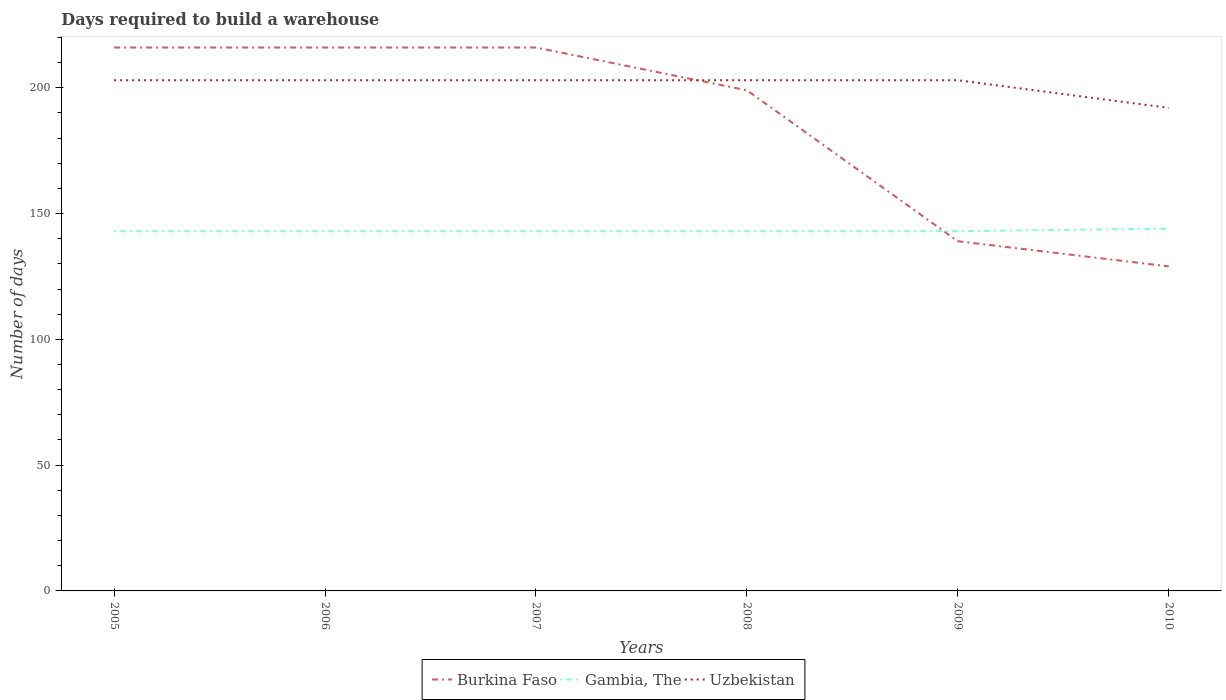Does the line corresponding to Uzbekistan intersect with the line corresponding to Burkina Faso?
Provide a short and direct response. Yes. Across all years, what is the maximum days required to build a warehouse in in Uzbekistan?
Your answer should be very brief. 192. In which year was the days required to build a warehouse in in Uzbekistan maximum?
Offer a very short reply. 2010. What is the total days required to build a warehouse in in Burkina Faso in the graph?
Offer a very short reply. 87. What is the difference between the highest and the second highest days required to build a warehouse in in Gambia, The?
Your response must be concise. 1. Is the days required to build a warehouse in in Uzbekistan strictly greater than the days required to build a warehouse in in Gambia, The over the years?
Keep it short and to the point. No. How many years are there in the graph?
Your answer should be compact. 6. Does the graph contain any zero values?
Provide a short and direct response. No. Does the graph contain grids?
Your answer should be compact. No. What is the title of the graph?
Ensure brevity in your answer.  Days required to build a warehouse. What is the label or title of the X-axis?
Provide a short and direct response. Years. What is the label or title of the Y-axis?
Keep it short and to the point. Number of days. What is the Number of days in Burkina Faso in 2005?
Your answer should be compact. 216. What is the Number of days of Gambia, The in 2005?
Give a very brief answer. 143. What is the Number of days in Uzbekistan in 2005?
Your answer should be compact. 203. What is the Number of days of Burkina Faso in 2006?
Give a very brief answer. 216. What is the Number of days of Gambia, The in 2006?
Offer a very short reply. 143. What is the Number of days in Uzbekistan in 2006?
Keep it short and to the point. 203. What is the Number of days in Burkina Faso in 2007?
Offer a terse response. 216. What is the Number of days of Gambia, The in 2007?
Give a very brief answer. 143. What is the Number of days in Uzbekistan in 2007?
Offer a very short reply. 203. What is the Number of days in Burkina Faso in 2008?
Give a very brief answer. 199. What is the Number of days in Gambia, The in 2008?
Give a very brief answer. 143. What is the Number of days in Uzbekistan in 2008?
Keep it short and to the point. 203. What is the Number of days in Burkina Faso in 2009?
Your answer should be compact. 139. What is the Number of days in Gambia, The in 2009?
Make the answer very short. 143. What is the Number of days of Uzbekistan in 2009?
Offer a terse response. 203. What is the Number of days of Burkina Faso in 2010?
Give a very brief answer. 129. What is the Number of days in Gambia, The in 2010?
Keep it short and to the point. 144. What is the Number of days in Uzbekistan in 2010?
Offer a terse response. 192. Across all years, what is the maximum Number of days in Burkina Faso?
Keep it short and to the point. 216. Across all years, what is the maximum Number of days of Gambia, The?
Ensure brevity in your answer.  144. Across all years, what is the maximum Number of days in Uzbekistan?
Ensure brevity in your answer.  203. Across all years, what is the minimum Number of days of Burkina Faso?
Provide a succinct answer. 129. Across all years, what is the minimum Number of days in Gambia, The?
Your answer should be compact. 143. Across all years, what is the minimum Number of days in Uzbekistan?
Give a very brief answer. 192. What is the total Number of days of Burkina Faso in the graph?
Ensure brevity in your answer.  1115. What is the total Number of days in Gambia, The in the graph?
Offer a very short reply. 859. What is the total Number of days of Uzbekistan in the graph?
Provide a succinct answer. 1207. What is the difference between the Number of days in Uzbekistan in 2005 and that in 2006?
Keep it short and to the point. 0. What is the difference between the Number of days of Burkina Faso in 2005 and that in 2007?
Your response must be concise. 0. What is the difference between the Number of days of Gambia, The in 2005 and that in 2007?
Your response must be concise. 0. What is the difference between the Number of days in Uzbekistan in 2005 and that in 2007?
Make the answer very short. 0. What is the difference between the Number of days of Burkina Faso in 2005 and that in 2008?
Ensure brevity in your answer.  17. What is the difference between the Number of days in Gambia, The in 2005 and that in 2008?
Ensure brevity in your answer.  0. What is the difference between the Number of days of Uzbekistan in 2005 and that in 2008?
Your answer should be compact. 0. What is the difference between the Number of days in Gambia, The in 2005 and that in 2009?
Offer a terse response. 0. What is the difference between the Number of days in Uzbekistan in 2005 and that in 2010?
Offer a terse response. 11. What is the difference between the Number of days of Burkina Faso in 2006 and that in 2007?
Provide a succinct answer. 0. What is the difference between the Number of days of Uzbekistan in 2006 and that in 2007?
Provide a short and direct response. 0. What is the difference between the Number of days of Uzbekistan in 2006 and that in 2008?
Your response must be concise. 0. What is the difference between the Number of days in Burkina Faso in 2006 and that in 2010?
Your answer should be compact. 87. What is the difference between the Number of days of Uzbekistan in 2006 and that in 2010?
Your response must be concise. 11. What is the difference between the Number of days of Burkina Faso in 2007 and that in 2008?
Provide a short and direct response. 17. What is the difference between the Number of days of Uzbekistan in 2007 and that in 2008?
Make the answer very short. 0. What is the difference between the Number of days in Burkina Faso in 2007 and that in 2009?
Your response must be concise. 77. What is the difference between the Number of days in Gambia, The in 2007 and that in 2009?
Your answer should be compact. 0. What is the difference between the Number of days in Gambia, The in 2007 and that in 2010?
Your answer should be compact. -1. What is the difference between the Number of days in Uzbekistan in 2007 and that in 2010?
Your answer should be very brief. 11. What is the difference between the Number of days in Uzbekistan in 2008 and that in 2009?
Make the answer very short. 0. What is the difference between the Number of days of Gambia, The in 2008 and that in 2010?
Give a very brief answer. -1. What is the difference between the Number of days of Uzbekistan in 2008 and that in 2010?
Make the answer very short. 11. What is the difference between the Number of days of Gambia, The in 2005 and the Number of days of Uzbekistan in 2006?
Offer a very short reply. -60. What is the difference between the Number of days in Burkina Faso in 2005 and the Number of days in Uzbekistan in 2007?
Make the answer very short. 13. What is the difference between the Number of days in Gambia, The in 2005 and the Number of days in Uzbekistan in 2007?
Offer a very short reply. -60. What is the difference between the Number of days of Burkina Faso in 2005 and the Number of days of Gambia, The in 2008?
Offer a very short reply. 73. What is the difference between the Number of days of Burkina Faso in 2005 and the Number of days of Uzbekistan in 2008?
Make the answer very short. 13. What is the difference between the Number of days of Gambia, The in 2005 and the Number of days of Uzbekistan in 2008?
Make the answer very short. -60. What is the difference between the Number of days of Gambia, The in 2005 and the Number of days of Uzbekistan in 2009?
Your response must be concise. -60. What is the difference between the Number of days of Burkina Faso in 2005 and the Number of days of Gambia, The in 2010?
Give a very brief answer. 72. What is the difference between the Number of days in Burkina Faso in 2005 and the Number of days in Uzbekistan in 2010?
Give a very brief answer. 24. What is the difference between the Number of days in Gambia, The in 2005 and the Number of days in Uzbekistan in 2010?
Provide a succinct answer. -49. What is the difference between the Number of days in Burkina Faso in 2006 and the Number of days in Gambia, The in 2007?
Keep it short and to the point. 73. What is the difference between the Number of days in Gambia, The in 2006 and the Number of days in Uzbekistan in 2007?
Your answer should be compact. -60. What is the difference between the Number of days of Burkina Faso in 2006 and the Number of days of Gambia, The in 2008?
Provide a short and direct response. 73. What is the difference between the Number of days of Gambia, The in 2006 and the Number of days of Uzbekistan in 2008?
Give a very brief answer. -60. What is the difference between the Number of days of Burkina Faso in 2006 and the Number of days of Uzbekistan in 2009?
Offer a very short reply. 13. What is the difference between the Number of days in Gambia, The in 2006 and the Number of days in Uzbekistan in 2009?
Ensure brevity in your answer.  -60. What is the difference between the Number of days of Burkina Faso in 2006 and the Number of days of Gambia, The in 2010?
Keep it short and to the point. 72. What is the difference between the Number of days in Burkina Faso in 2006 and the Number of days in Uzbekistan in 2010?
Offer a terse response. 24. What is the difference between the Number of days of Gambia, The in 2006 and the Number of days of Uzbekistan in 2010?
Keep it short and to the point. -49. What is the difference between the Number of days in Burkina Faso in 2007 and the Number of days in Gambia, The in 2008?
Ensure brevity in your answer.  73. What is the difference between the Number of days of Burkina Faso in 2007 and the Number of days of Uzbekistan in 2008?
Keep it short and to the point. 13. What is the difference between the Number of days in Gambia, The in 2007 and the Number of days in Uzbekistan in 2008?
Keep it short and to the point. -60. What is the difference between the Number of days in Burkina Faso in 2007 and the Number of days in Gambia, The in 2009?
Make the answer very short. 73. What is the difference between the Number of days of Gambia, The in 2007 and the Number of days of Uzbekistan in 2009?
Your answer should be compact. -60. What is the difference between the Number of days in Burkina Faso in 2007 and the Number of days in Uzbekistan in 2010?
Offer a terse response. 24. What is the difference between the Number of days in Gambia, The in 2007 and the Number of days in Uzbekistan in 2010?
Your answer should be compact. -49. What is the difference between the Number of days of Burkina Faso in 2008 and the Number of days of Gambia, The in 2009?
Give a very brief answer. 56. What is the difference between the Number of days of Gambia, The in 2008 and the Number of days of Uzbekistan in 2009?
Provide a succinct answer. -60. What is the difference between the Number of days in Burkina Faso in 2008 and the Number of days in Gambia, The in 2010?
Give a very brief answer. 55. What is the difference between the Number of days of Burkina Faso in 2008 and the Number of days of Uzbekistan in 2010?
Offer a terse response. 7. What is the difference between the Number of days in Gambia, The in 2008 and the Number of days in Uzbekistan in 2010?
Your response must be concise. -49. What is the difference between the Number of days in Burkina Faso in 2009 and the Number of days in Gambia, The in 2010?
Ensure brevity in your answer.  -5. What is the difference between the Number of days in Burkina Faso in 2009 and the Number of days in Uzbekistan in 2010?
Provide a succinct answer. -53. What is the difference between the Number of days in Gambia, The in 2009 and the Number of days in Uzbekistan in 2010?
Offer a very short reply. -49. What is the average Number of days of Burkina Faso per year?
Offer a very short reply. 185.83. What is the average Number of days in Gambia, The per year?
Give a very brief answer. 143.17. What is the average Number of days of Uzbekistan per year?
Make the answer very short. 201.17. In the year 2005, what is the difference between the Number of days in Gambia, The and Number of days in Uzbekistan?
Provide a succinct answer. -60. In the year 2006, what is the difference between the Number of days of Burkina Faso and Number of days of Gambia, The?
Make the answer very short. 73. In the year 2006, what is the difference between the Number of days in Burkina Faso and Number of days in Uzbekistan?
Offer a very short reply. 13. In the year 2006, what is the difference between the Number of days of Gambia, The and Number of days of Uzbekistan?
Keep it short and to the point. -60. In the year 2007, what is the difference between the Number of days of Burkina Faso and Number of days of Gambia, The?
Ensure brevity in your answer.  73. In the year 2007, what is the difference between the Number of days of Burkina Faso and Number of days of Uzbekistan?
Keep it short and to the point. 13. In the year 2007, what is the difference between the Number of days in Gambia, The and Number of days in Uzbekistan?
Give a very brief answer. -60. In the year 2008, what is the difference between the Number of days of Burkina Faso and Number of days of Gambia, The?
Provide a short and direct response. 56. In the year 2008, what is the difference between the Number of days of Gambia, The and Number of days of Uzbekistan?
Provide a short and direct response. -60. In the year 2009, what is the difference between the Number of days of Burkina Faso and Number of days of Gambia, The?
Your answer should be very brief. -4. In the year 2009, what is the difference between the Number of days in Burkina Faso and Number of days in Uzbekistan?
Your answer should be compact. -64. In the year 2009, what is the difference between the Number of days in Gambia, The and Number of days in Uzbekistan?
Offer a terse response. -60. In the year 2010, what is the difference between the Number of days of Burkina Faso and Number of days of Gambia, The?
Your answer should be very brief. -15. In the year 2010, what is the difference between the Number of days in Burkina Faso and Number of days in Uzbekistan?
Keep it short and to the point. -63. In the year 2010, what is the difference between the Number of days of Gambia, The and Number of days of Uzbekistan?
Offer a terse response. -48. What is the ratio of the Number of days of Burkina Faso in 2005 to that in 2006?
Ensure brevity in your answer.  1. What is the ratio of the Number of days of Gambia, The in 2005 to that in 2006?
Offer a terse response. 1. What is the ratio of the Number of days of Gambia, The in 2005 to that in 2007?
Offer a terse response. 1. What is the ratio of the Number of days of Uzbekistan in 2005 to that in 2007?
Keep it short and to the point. 1. What is the ratio of the Number of days of Burkina Faso in 2005 to that in 2008?
Provide a succinct answer. 1.09. What is the ratio of the Number of days of Uzbekistan in 2005 to that in 2008?
Your answer should be compact. 1. What is the ratio of the Number of days of Burkina Faso in 2005 to that in 2009?
Your answer should be compact. 1.55. What is the ratio of the Number of days of Gambia, The in 2005 to that in 2009?
Give a very brief answer. 1. What is the ratio of the Number of days in Uzbekistan in 2005 to that in 2009?
Give a very brief answer. 1. What is the ratio of the Number of days in Burkina Faso in 2005 to that in 2010?
Provide a succinct answer. 1.67. What is the ratio of the Number of days in Uzbekistan in 2005 to that in 2010?
Make the answer very short. 1.06. What is the ratio of the Number of days in Burkina Faso in 2006 to that in 2007?
Give a very brief answer. 1. What is the ratio of the Number of days in Burkina Faso in 2006 to that in 2008?
Your response must be concise. 1.09. What is the ratio of the Number of days in Gambia, The in 2006 to that in 2008?
Offer a very short reply. 1. What is the ratio of the Number of days in Burkina Faso in 2006 to that in 2009?
Make the answer very short. 1.55. What is the ratio of the Number of days of Gambia, The in 2006 to that in 2009?
Offer a very short reply. 1. What is the ratio of the Number of days in Uzbekistan in 2006 to that in 2009?
Keep it short and to the point. 1. What is the ratio of the Number of days in Burkina Faso in 2006 to that in 2010?
Offer a very short reply. 1.67. What is the ratio of the Number of days in Uzbekistan in 2006 to that in 2010?
Offer a terse response. 1.06. What is the ratio of the Number of days in Burkina Faso in 2007 to that in 2008?
Provide a short and direct response. 1.09. What is the ratio of the Number of days in Uzbekistan in 2007 to that in 2008?
Ensure brevity in your answer.  1. What is the ratio of the Number of days of Burkina Faso in 2007 to that in 2009?
Offer a very short reply. 1.55. What is the ratio of the Number of days of Gambia, The in 2007 to that in 2009?
Keep it short and to the point. 1. What is the ratio of the Number of days in Burkina Faso in 2007 to that in 2010?
Provide a succinct answer. 1.67. What is the ratio of the Number of days in Uzbekistan in 2007 to that in 2010?
Your answer should be compact. 1.06. What is the ratio of the Number of days of Burkina Faso in 2008 to that in 2009?
Offer a very short reply. 1.43. What is the ratio of the Number of days of Burkina Faso in 2008 to that in 2010?
Ensure brevity in your answer.  1.54. What is the ratio of the Number of days in Uzbekistan in 2008 to that in 2010?
Give a very brief answer. 1.06. What is the ratio of the Number of days in Burkina Faso in 2009 to that in 2010?
Offer a very short reply. 1.08. What is the ratio of the Number of days of Uzbekistan in 2009 to that in 2010?
Your answer should be compact. 1.06. What is the difference between the highest and the second highest Number of days in Burkina Faso?
Keep it short and to the point. 0. What is the difference between the highest and the lowest Number of days of Burkina Faso?
Keep it short and to the point. 87. What is the difference between the highest and the lowest Number of days in Gambia, The?
Provide a short and direct response. 1. What is the difference between the highest and the lowest Number of days of Uzbekistan?
Make the answer very short. 11. 